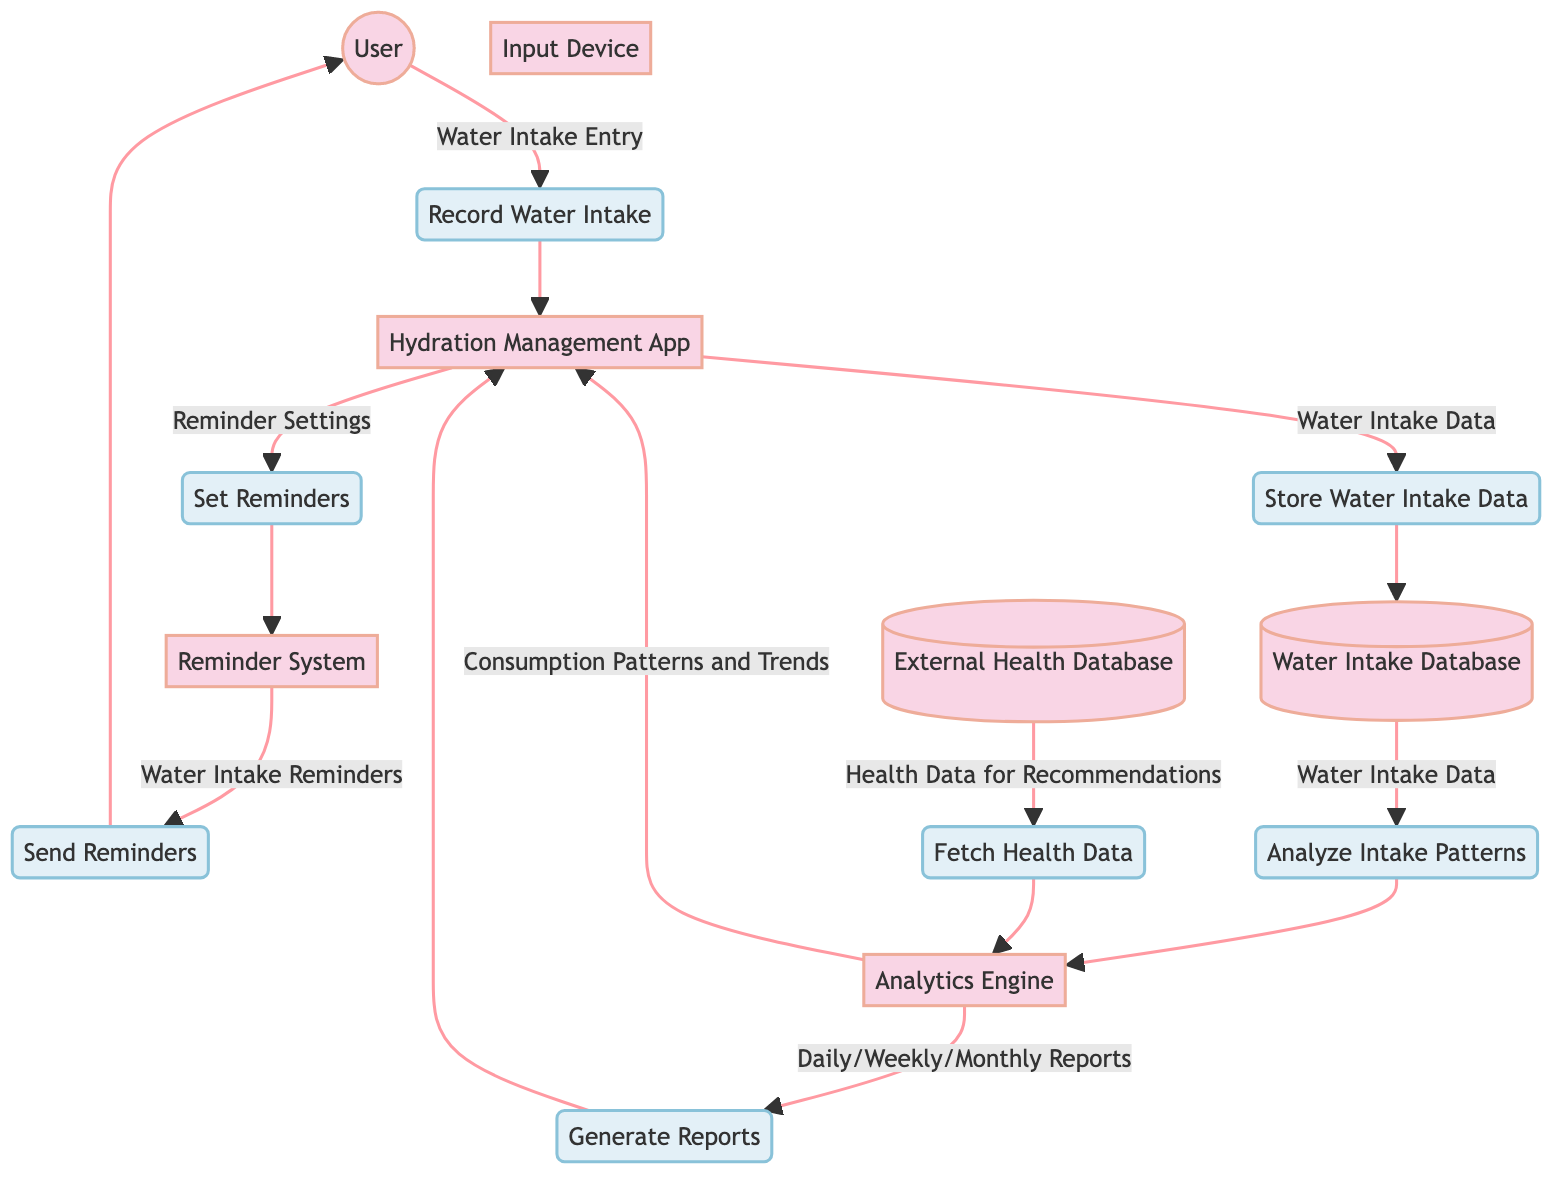What is the main input from the user? The main input from the user is "Water Intake Entry," which is sent to the "Record Water Intake" process.
Answer: Water Intake Entry How many entities are in the diagram? The diagram lists 7 entities: User, Hydration Management App, Input Device, Reminder System, Water Intake Database, Analytics Engine, and External Health Database.
Answer: 7 Which process is responsible for sending alerts to the user? The "Send Reminders" process is responsible for sending water intake reminders to the user.
Answer: Send Reminders What type of data does the Analytics Engine send back to the Hydration Management App? The Analytics Engine sends "Consumption Patterns and Trends" back to the Hydration Management App.
Answer: Consumption Patterns and Trends Which two outputs come from the Analytics Engine? The Analytics Engine sends "Consumption Patterns and Trends" and "Daily/Weekly/Monthly Reports" to the Hydration Management App.
Answer: Consumption Patterns and Trends, Daily/Weekly/Monthly Reports What process retrieves health-related data for recommendations? The "Fetch Health Data" process retrieves health-related data from the External Health Database for personalized recommendations.
Answer: Fetch Health Data How is water intake data stored in the system? Water intake data is stored through the "Store Water Intake Data" process which takes input from the Hydration Management App.
Answer: Store Water Intake Data What entity collects the user’s water intake data? The Hydration Management App collects the user's water intake data.
Answer: Hydration Management App 